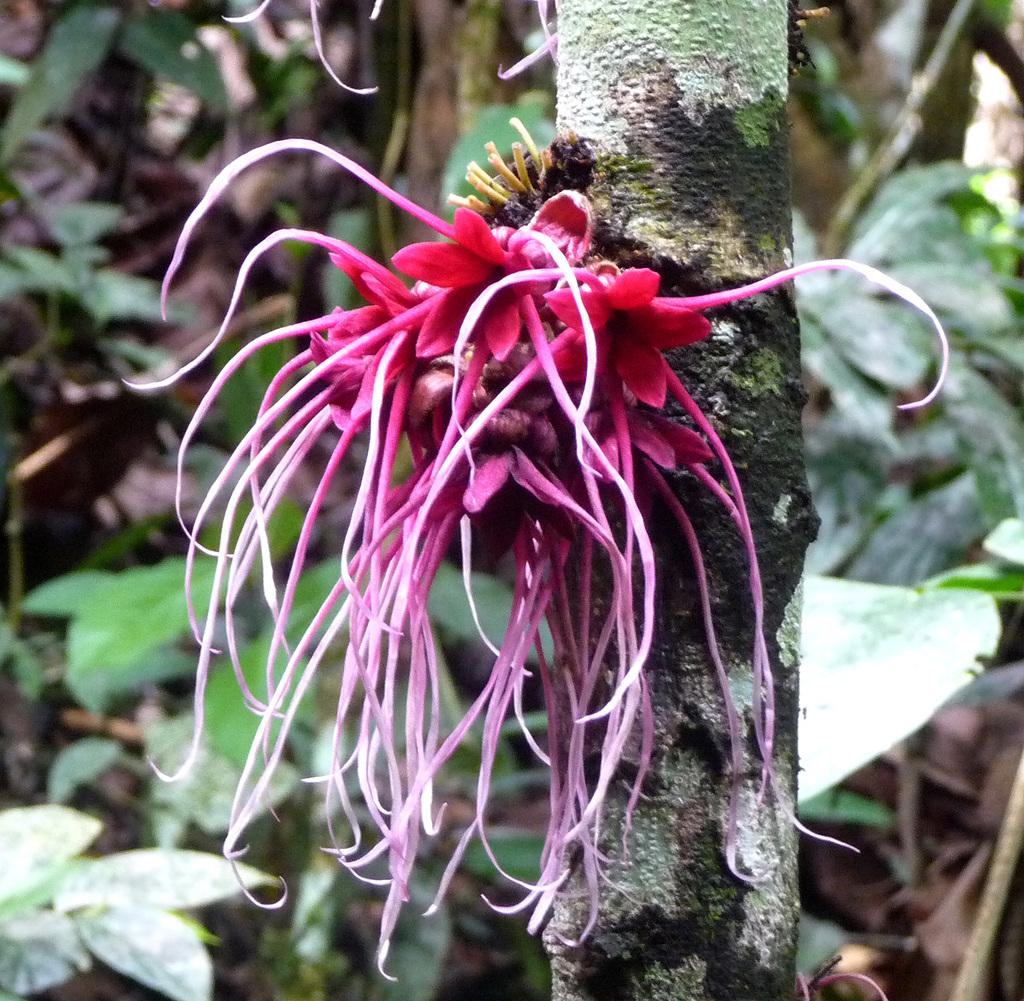What is the main subject in the center of the image? There is a flower plant in the center of the image. What else can be seen in the background of the image? There are other plants in the background of the image. What type of glove is being worn by the partner in the image? There is no partner or glove present in the image; it only features a flower plant and other plants in the background. 